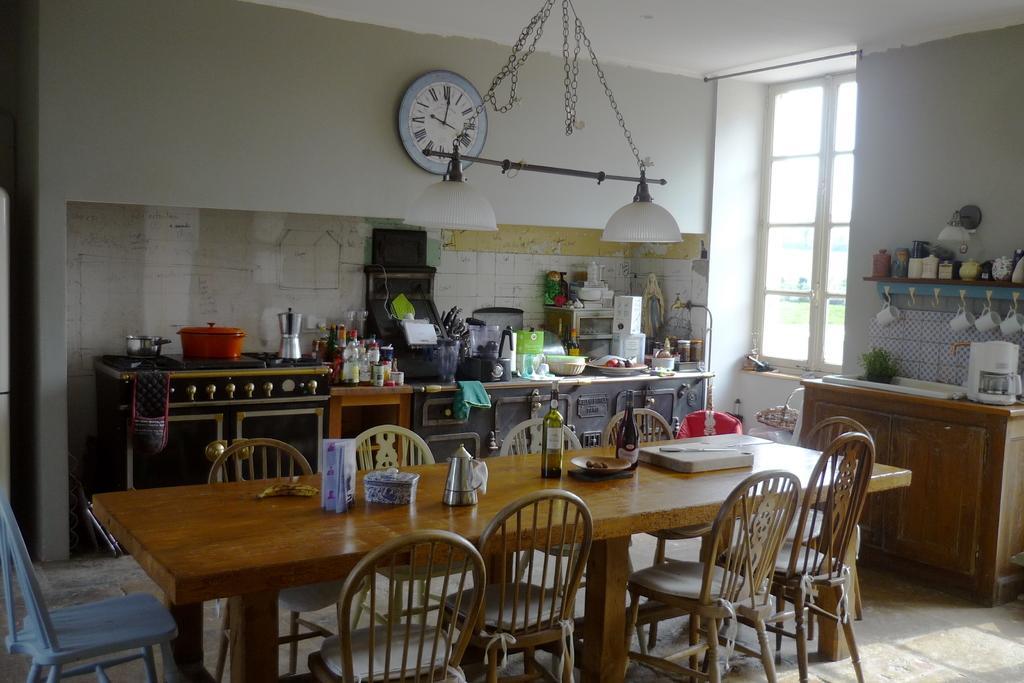Describe this image in one or two sentences. This is a picture of kitchen here we can see the dining table which consists of ten chairs around it. In the dining table we can see the different items such as bottle,chopping,kettle,tissue paper and banana. Beside that we can see the wall. here there are number of items present in the kitchen , there is also a window which is near to the wall and there is also a table and there area different cups hanging on the stand and here we can also see a lamp hanging on the wall.. 